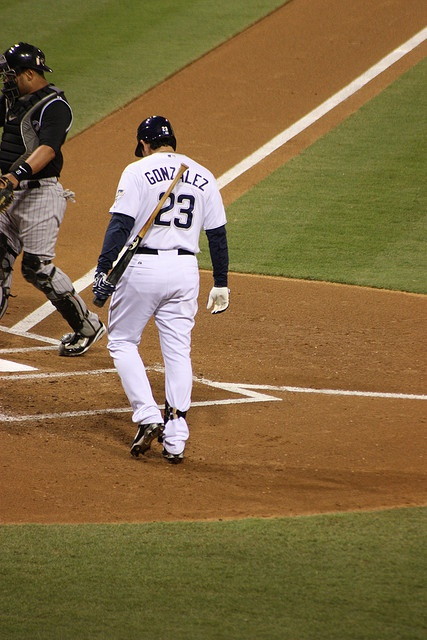Describe the objects in this image and their specific colors. I can see people in darkgreen, lavender, black, and darkgray tones, people in darkgreen, black, darkgray, gray, and olive tones, baseball bat in darkgreen, black, olive, tan, and lavender tones, and baseball glove in darkgreen, black, olive, brown, and maroon tones in this image. 